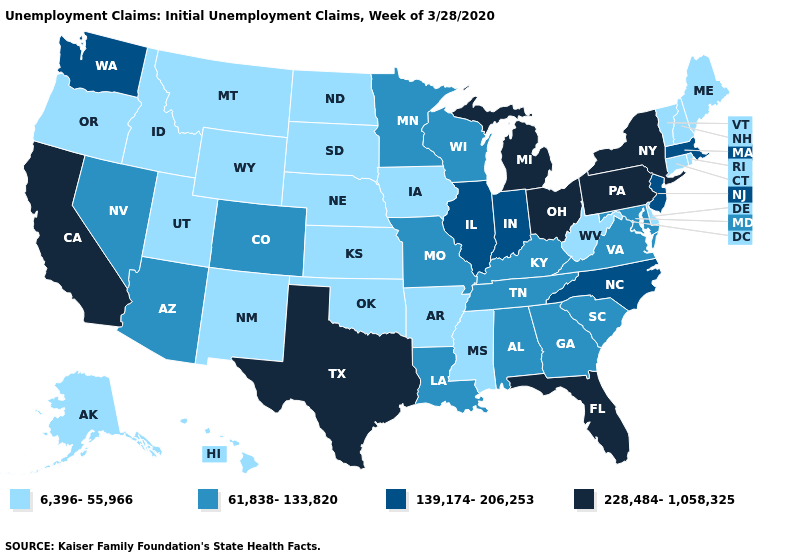What is the highest value in the USA?
Write a very short answer. 228,484-1,058,325. Which states have the highest value in the USA?
Write a very short answer. California, Florida, Michigan, New York, Ohio, Pennsylvania, Texas. What is the lowest value in the West?
Be succinct. 6,396-55,966. Does South Dakota have the lowest value in the MidWest?
Write a very short answer. Yes. Among the states that border California , which have the lowest value?
Give a very brief answer. Oregon. Among the states that border Illinois , does Missouri have the lowest value?
Keep it brief. No. What is the value of Massachusetts?
Short answer required. 139,174-206,253. Which states hav the highest value in the South?
Keep it brief. Florida, Texas. Does New Mexico have the lowest value in the USA?
Answer briefly. Yes. Name the states that have a value in the range 61,838-133,820?
Quick response, please. Alabama, Arizona, Colorado, Georgia, Kentucky, Louisiana, Maryland, Minnesota, Missouri, Nevada, South Carolina, Tennessee, Virginia, Wisconsin. Does South Carolina have the lowest value in the South?
Keep it brief. No. What is the value of Oklahoma?
Answer briefly. 6,396-55,966. What is the value of Washington?
Quick response, please. 139,174-206,253. Name the states that have a value in the range 228,484-1,058,325?
Quick response, please. California, Florida, Michigan, New York, Ohio, Pennsylvania, Texas. Name the states that have a value in the range 6,396-55,966?
Write a very short answer. Alaska, Arkansas, Connecticut, Delaware, Hawaii, Idaho, Iowa, Kansas, Maine, Mississippi, Montana, Nebraska, New Hampshire, New Mexico, North Dakota, Oklahoma, Oregon, Rhode Island, South Dakota, Utah, Vermont, West Virginia, Wyoming. 